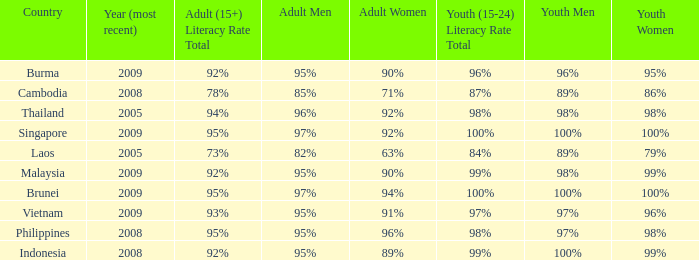Which country has its most recent year as being 2005 and has an Adult Men literacy rate of 96%? Thailand. 